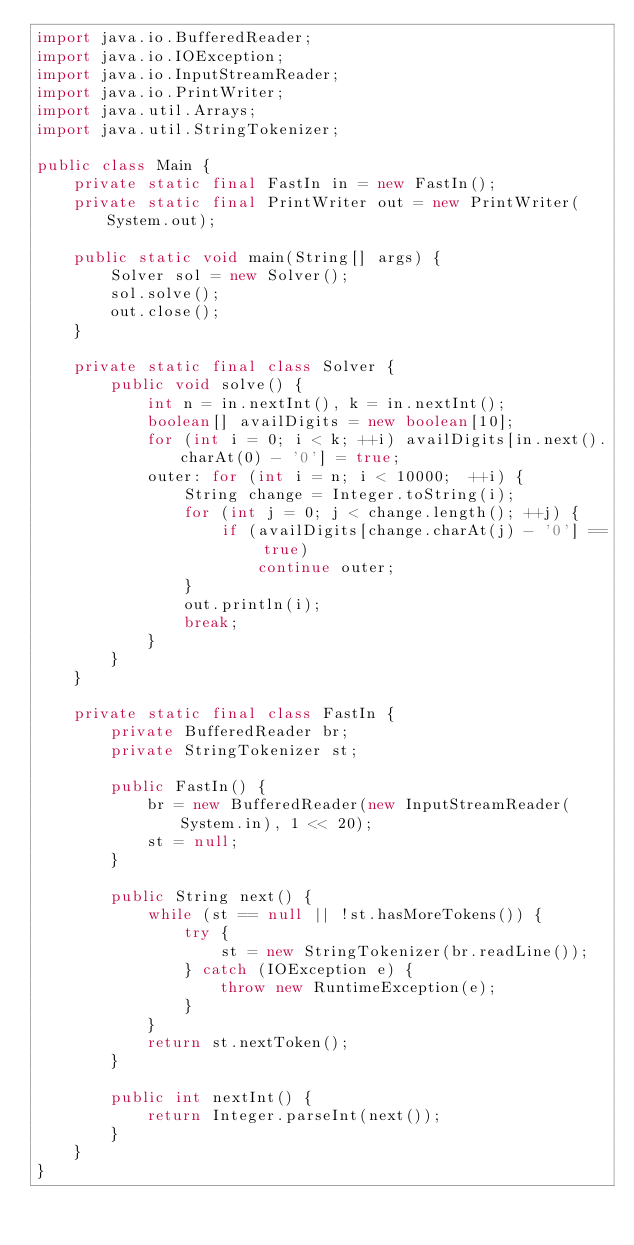Convert code to text. <code><loc_0><loc_0><loc_500><loc_500><_Java_>import java.io.BufferedReader;
import java.io.IOException;
import java.io.InputStreamReader;
import java.io.PrintWriter;
import java.util.Arrays;
import java.util.StringTokenizer;

public class Main {
	private static final FastIn in = new FastIn();
	private static final PrintWriter out = new PrintWriter(System.out);

	public static void main(String[] args) {
		Solver sol = new Solver();
		sol.solve();
		out.close();
	}

	private static final class Solver {
		public void solve() {
			int n = in.nextInt(), k = in.nextInt();
			boolean[] availDigits = new boolean[10];
			for (int i = 0; i < k; ++i) availDigits[in.next().charAt(0) - '0'] = true;
			outer: for (int i = n; i < 10000;  ++i) {
				String change = Integer.toString(i);
				for (int j = 0; j < change.length(); ++j) {
					if (availDigits[change.charAt(j) - '0'] == true)
						continue outer;
				}
				out.println(i);
				break;
			}
		}
	}

	private static final class FastIn {
		private BufferedReader br;
		private StringTokenizer st;

		public FastIn() {
			br = new BufferedReader(new InputStreamReader(System.in), 1 << 20);
			st = null;
		}

		public String next() {
			while (st == null || !st.hasMoreTokens()) {
				try {
					st = new StringTokenizer(br.readLine());
				} catch (IOException e) {
					throw new RuntimeException(e);
				}
			}
			return st.nextToken();
		}

		public int nextInt() {
			return Integer.parseInt(next());
		}
	}
}
</code> 